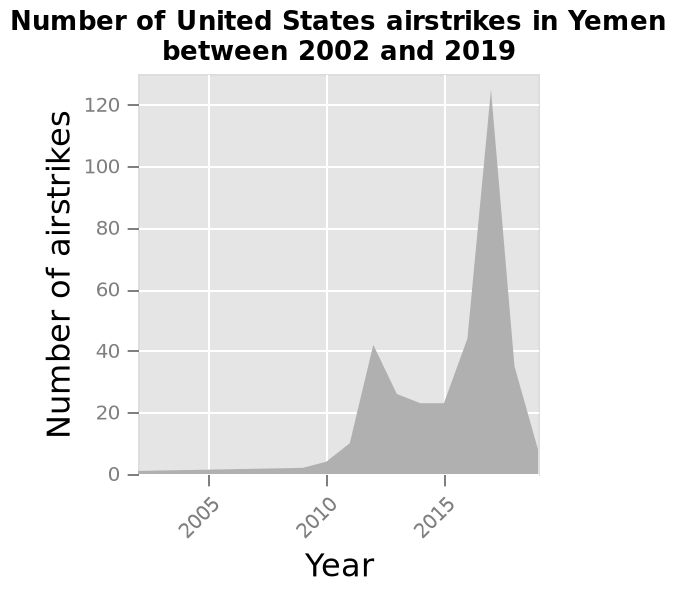<image>
please summary the statistics and relations of the chart There was an increasing trend in air strikes from 2010 increasing to a peak at 2017. It reduced dramatically after this. When did the trend of air strikes start to increase?  The trend of air strikes started to increase in 2010. When did the air strikes reach their highest point?  The air strikes reached their highest point in 2017. please describe the details of the chart Number of United States airstrikes in Yemen between 2002 and 2019 is a area chart. The y-axis shows Number of airstrikes while the x-axis measures Year. What does the y-axis represent in the area chart? The y-axis represents the number of airstrikes. Did the air strikes decrease from 2010 to a trough at 2017 and then increase dramatically after this? No.There was an increasing trend in air strikes from 2010 increasing to a peak at 2017. It reduced dramatically after this. 